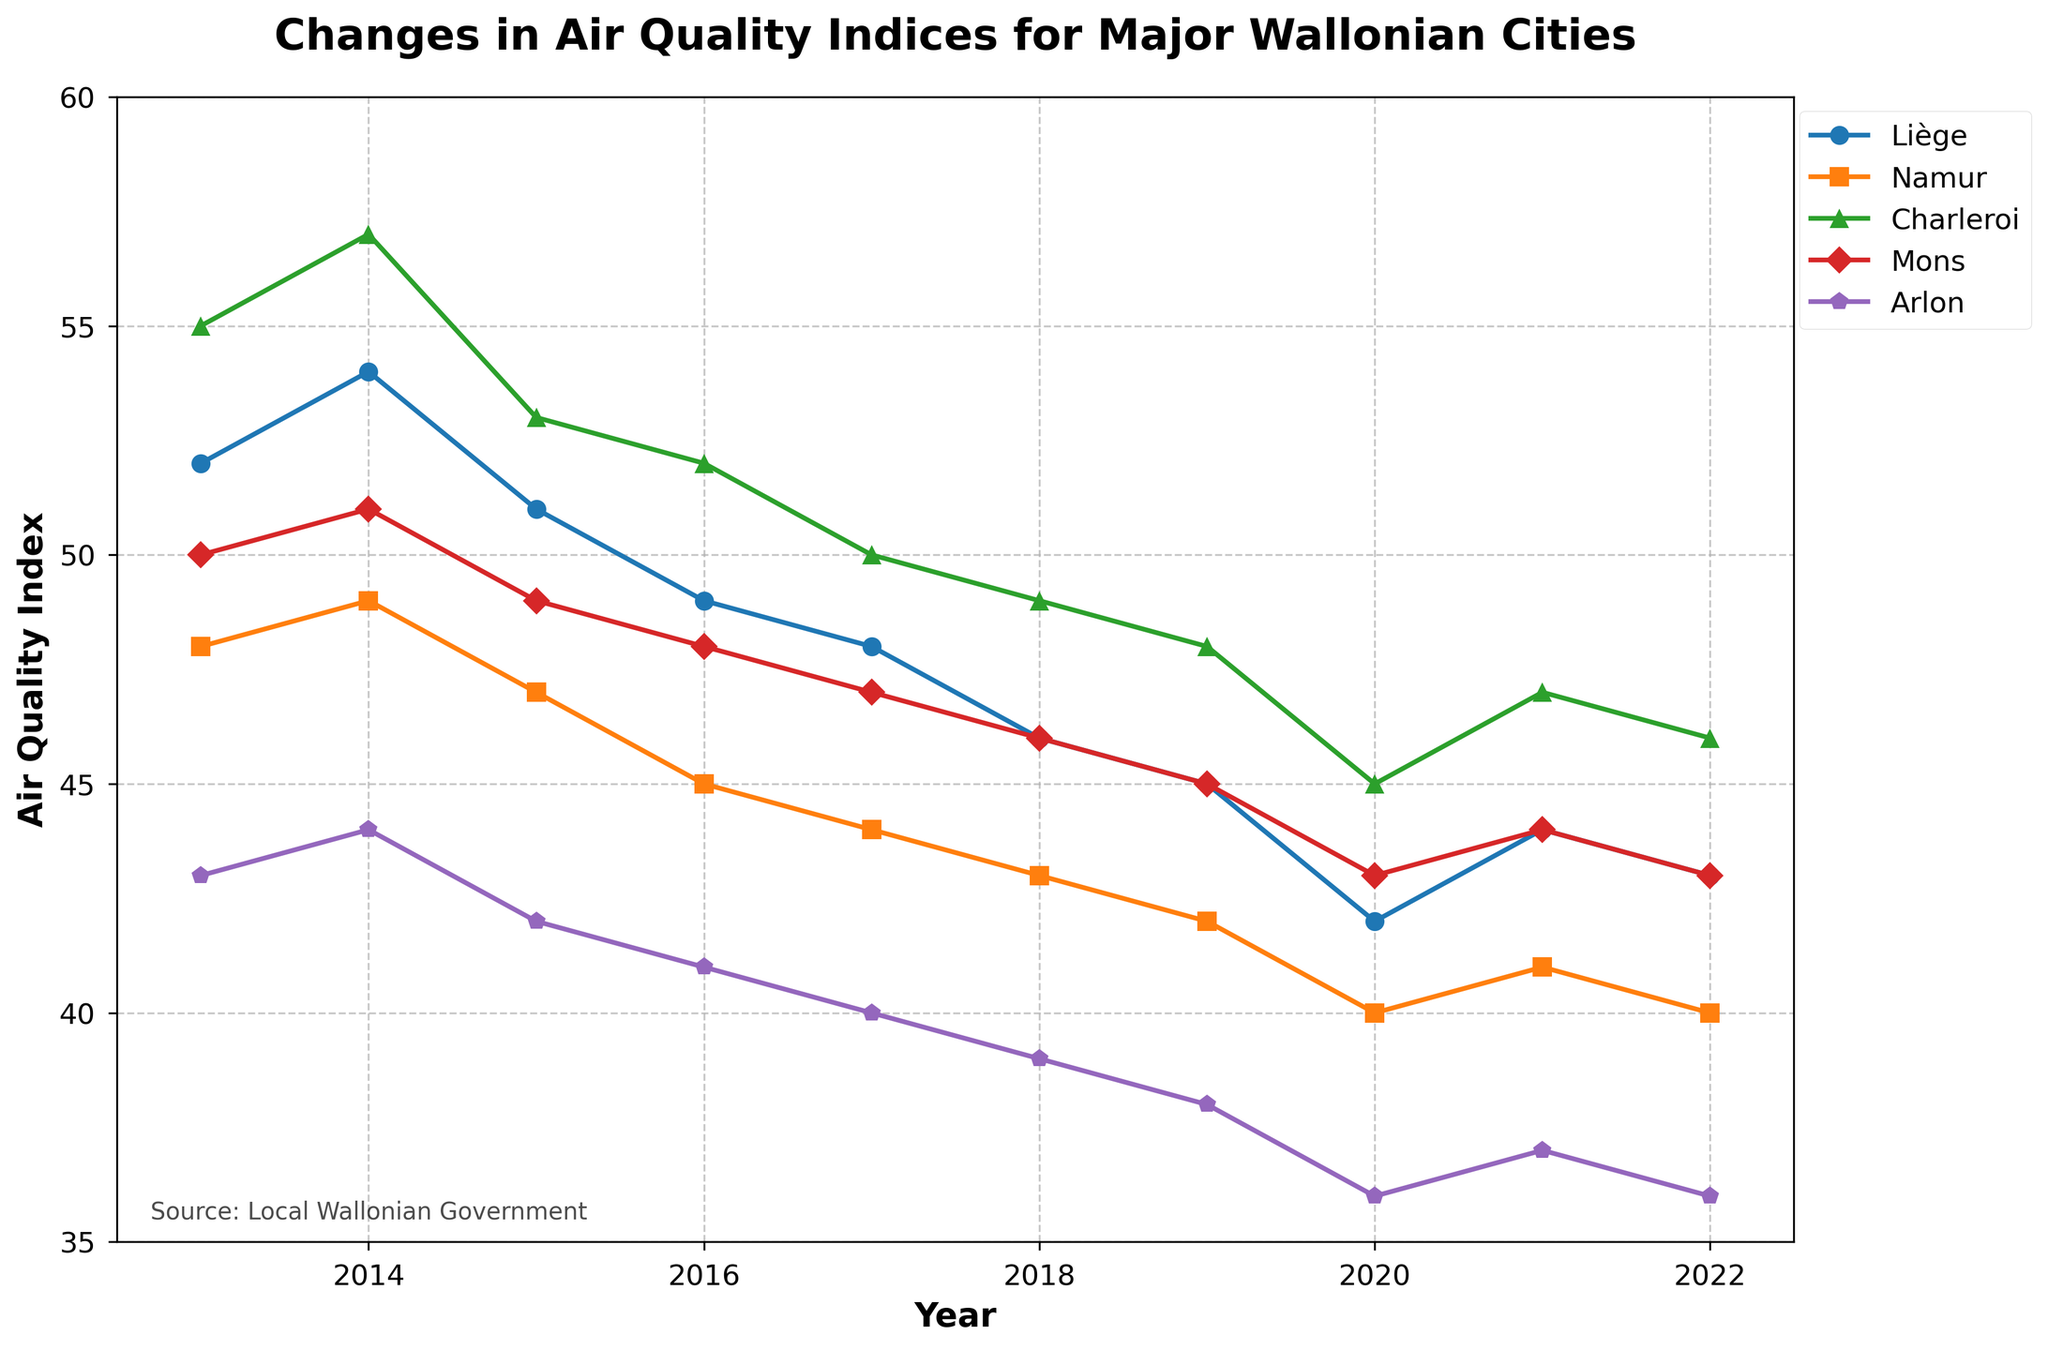Which city had the highest Air Quality Index (AQI) in 2022? Check the plot for each city's AQI in 2022. Liège has the highest AQI with a value of 43.
Answer: Liège How did the AQI of Namur change from 2013 to 2022? Observing the plot for Namur, the AQI decreases from 48 in 2013 to 40 in 2022. Thus, it has decreased by 8 points over the period.
Answer: Decreased by 8 Compare the AQI trends of Charleroi and Mons between 2013 and 2022. Which city saw a greater reduction? Charleroi's AQI dropped from 55 to 46, a reduction of 9 points. Mons' AQI dropped from 50 to 43, a reduction of 7 points. Therefore, Charleroi saw a greater reduction.
Answer: Charleroi Among the five cities, which city exhibited the most consistent decrease in AQI over the decade? By visually comparing the slopes of the lines, Arlon shows a consistent downward trend without any increases over the decade.
Answer: Arlon What was the initial difference between the AQI of Liège and Arlon in 2013, and how did this difference change by 2022? In 2013, the difference was 52 (Liège) - 43 (Arlon) = 9. In 2022, it was 43 (Liège) - 36 (Arlon) = 7. The difference decreased by 2.
Answer: Decreased by 2 Identify the year when Mons had its lowest AQI. By looking at the plotted points for Mons, 2020 shows the lowest AQI value of 43.
Answer: 2020 Which city's AQI fluctuated the most over the decade? Namur and Mons have fairly stable trends, but Charleroi (from 55 to 46) and Liège (from 52 to 43) had more noticeable fluctuations. Liège appears to have the largest range of values.
Answer: Liège Determine the average AQI for Arlon over the decade. Sum the AQI values for Arlon (43, 44, 42, 41, 40, 39, 38, 36, 37, 36) which equal 396. Divide by 10 to get the average, 396 / 10 = 39.6.
Answer: 39.6 During which period did Liège experience the sharpest decline in AQI? The sharpest decline occurred between 2019 (45) and 2020 (42), a drop of 3 points.
Answer: 2019-2020 In 2021, which city had an AQI close to the median AQI value for that year? The AQI values in 2021 are 44, 41, 47, 44, and 37. The median value when sorted (37, 41, 44, 44, 47) is 44, which matches Mons.
Answer: Mons and Liège 